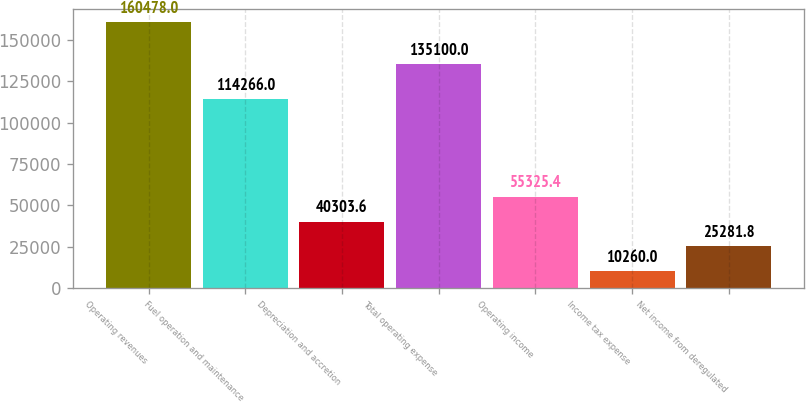Convert chart. <chart><loc_0><loc_0><loc_500><loc_500><bar_chart><fcel>Operating revenues<fcel>Fuel operation and maintenance<fcel>Depreciation and accretion<fcel>Total operating expense<fcel>Operating income<fcel>Income tax expense<fcel>Net income from deregulated<nl><fcel>160478<fcel>114266<fcel>40303.6<fcel>135100<fcel>55325.4<fcel>10260<fcel>25281.8<nl></chart> 